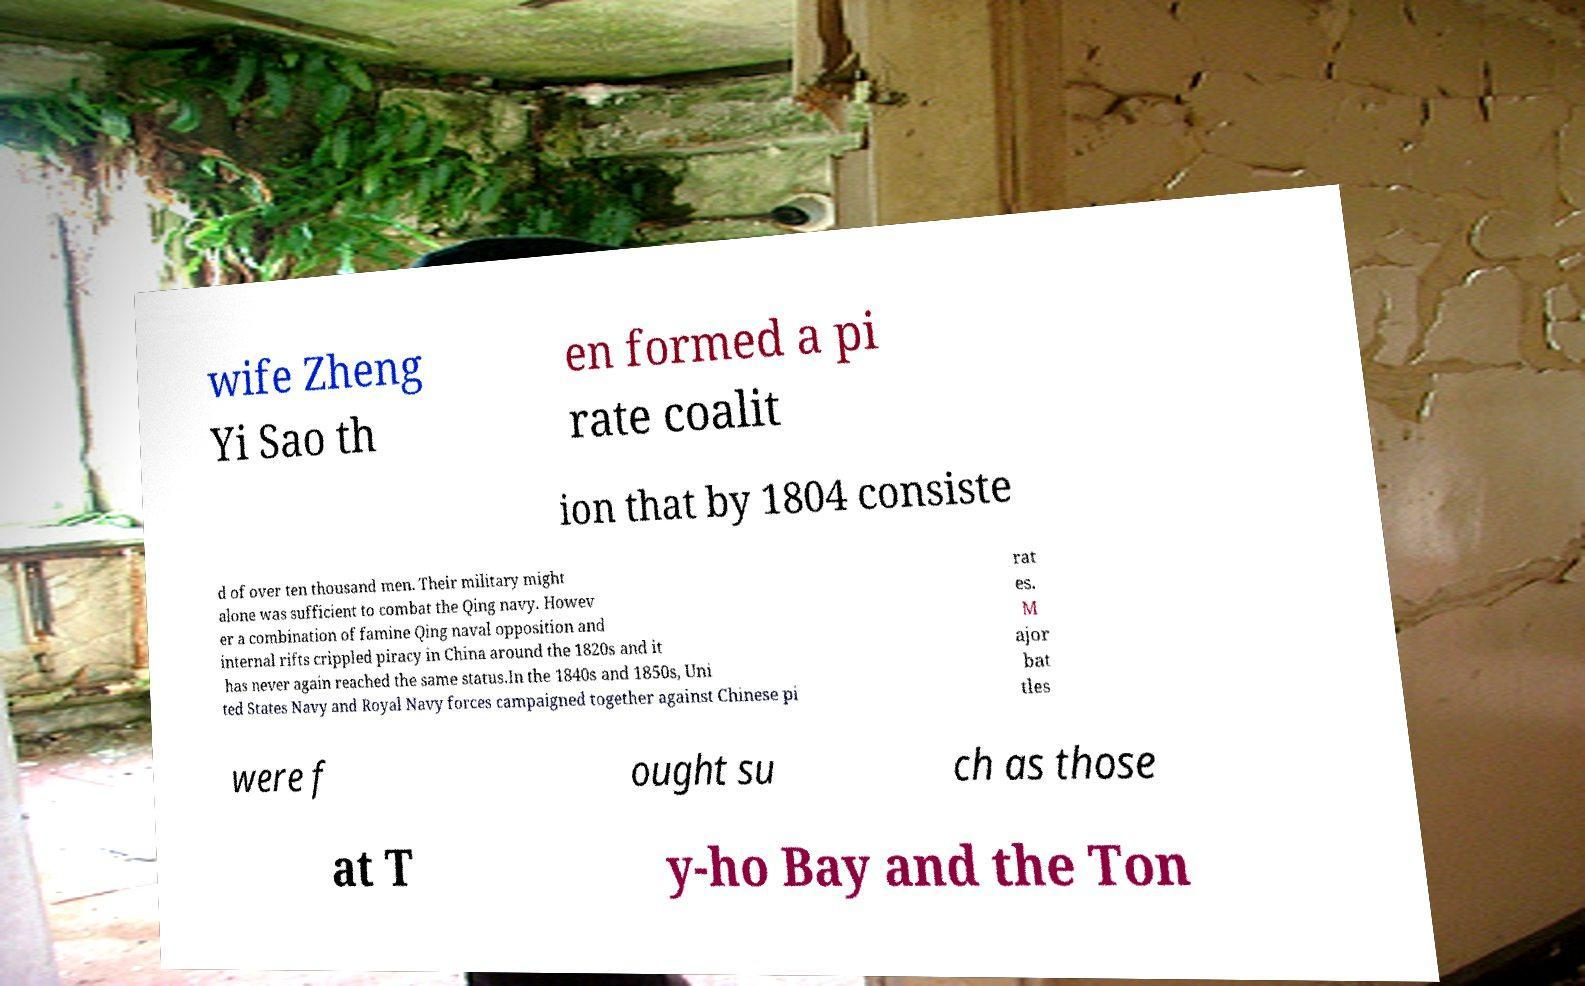Please read and relay the text visible in this image. What does it say? wife Zheng Yi Sao th en formed a pi rate coalit ion that by 1804 consiste d of over ten thousand men. Their military might alone was sufficient to combat the Qing navy. Howev er a combination of famine Qing naval opposition and internal rifts crippled piracy in China around the 1820s and it has never again reached the same status.In the 1840s and 1850s, Uni ted States Navy and Royal Navy forces campaigned together against Chinese pi rat es. M ajor bat tles were f ought su ch as those at T y-ho Bay and the Ton 